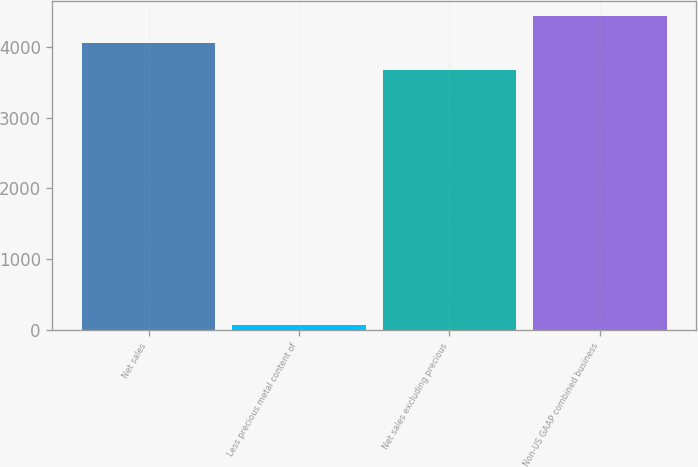Convert chart to OTSL. <chart><loc_0><loc_0><loc_500><loc_500><bar_chart><fcel>Net sales<fcel>Less precious metal content of<fcel>Net sales excluding precious<fcel>Non-US GAAP combined business<nl><fcel>4060.04<fcel>64.3<fcel>3681<fcel>4439.08<nl></chart> 